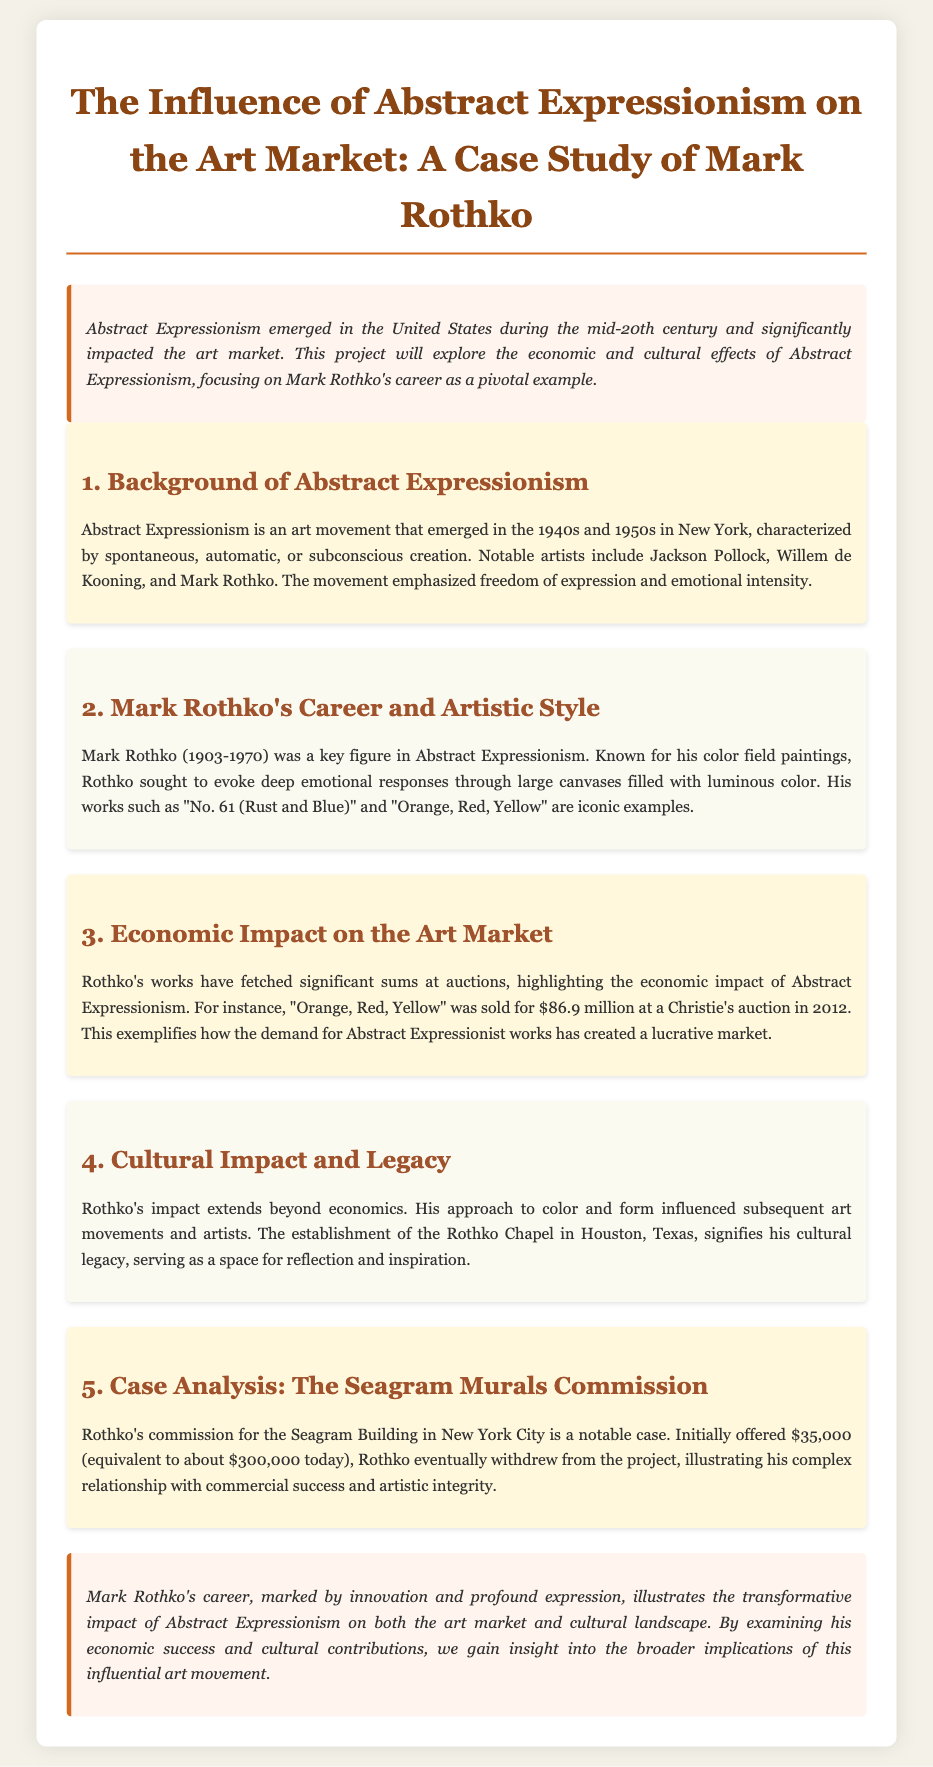What year did Abstract Expressionism emerge? The document states that Abstract Expressionism emerged in the United States during the mid-20th century.
Answer: mid-20th century Who is described as a key figure in Abstract Expressionism? The document mentions Mark Rothko as a key figure in Abstract Expressionism.
Answer: Mark Rothko What is the iconic work sold for $86.9 million? The document specifies that "Orange, Red, Yellow" was sold for $86.9 million at a Christie's auction in 2012.
Answer: Orange, Red, Yellow What was the original commission amount for the Seagram Murals? The document indicates that Rothko was initially offered $35,000 for the Seagram Murals commission.
Answer: $35,000 Which notable structure represents Rothko's cultural legacy? The document highlights the establishment of the Rothko Chapel as a representation of his cultural legacy.
Answer: Rothko Chapel What was Rothko's approach to color aimed at evoking? The document describes Rothko's approach as aimed at evoking deep emotional responses.
Answer: deep emotional responses What significant event occurred regarding "Orange, Red, Yellow" in 2012? The document states that "Orange, Red, Yellow" was sold at a Christie's auction for a substantial amount.
Answer: sold for $86.9 million What does the conclusion of the document emphasize about Rothko's impact? The conclusion emphasizes the transformative impact of Abstract Expressionism on both the art market and cultural landscape through Rothko's career.
Answer: transformative impact 